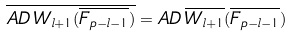Convert formula to latex. <formula><loc_0><loc_0><loc_500><loc_500>\overline { A D \, W _ { l + 1 } ( \overline { F _ { p - l - 1 } } ) } = A D \, \overline { W _ { l + 1 } } ( \overline { F _ { p - l - 1 } } )</formula> 